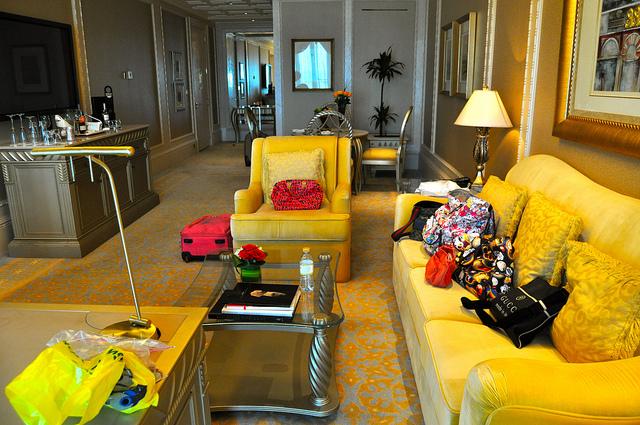Are there any lamps on?
Answer briefly. Yes. Is this a living area?
Be succinct. Yes. What is sitting on the couch?
Keep it brief. Purses. 